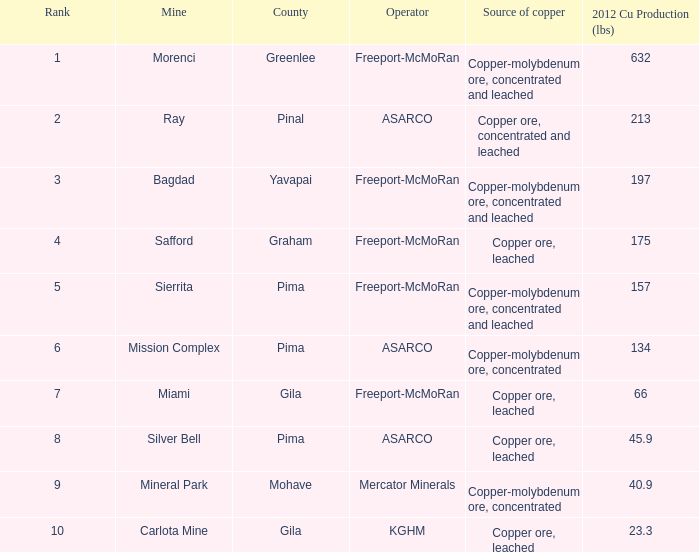What's the lowest ranking source of copper, copper ore, concentrated and leached? 2.0. 